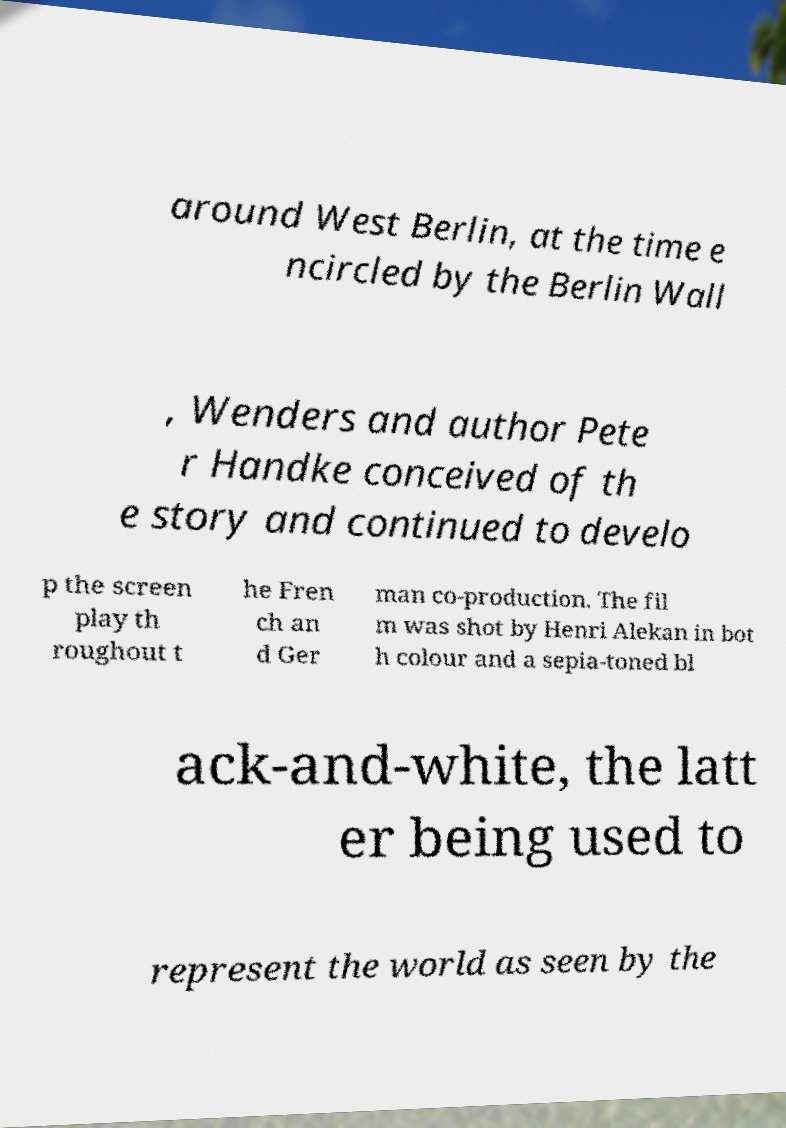Can you accurately transcribe the text from the provided image for me? around West Berlin, at the time e ncircled by the Berlin Wall , Wenders and author Pete r Handke conceived of th e story and continued to develo p the screen play th roughout t he Fren ch an d Ger man co-production. The fil m was shot by Henri Alekan in bot h colour and a sepia-toned bl ack-and-white, the latt er being used to represent the world as seen by the 